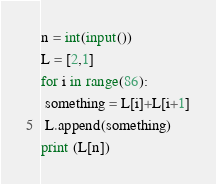<code> <loc_0><loc_0><loc_500><loc_500><_Python_>n = int(input())
L = [2,1]
for i in range(86):
 something = L[i]+L[i+1]
 L.append(something)
print (L[n])
</code> 